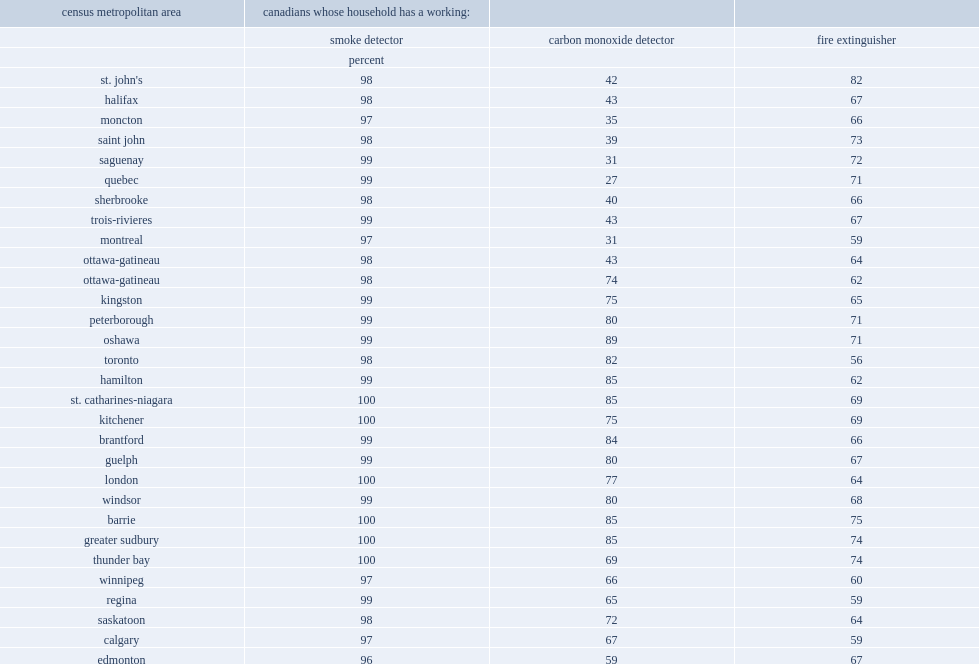Parse the table in full. {'header': ['census metropolitan area', 'canadians whose household has a working:', '', ''], 'rows': [['', 'smoke detector', 'carbon monoxide detector', 'fire extinguisher'], ['', 'percent', '', ''], ["st. john's", '98', '42', '82'], ['halifax', '98', '43', '67'], ['moncton', '97', '35', '66'], ['saint john', '98', '39', '73'], ['saguenay', '99', '31', '72'], ['quebec', '99', '27', '71'], ['sherbrooke', '98', '40', '66'], ['trois-rivieres', '99', '43', '67'], ['montreal', '97', '31', '59'], ['ottawa-gatineau', '98', '43', '64'], ['ottawa-gatineau', '98', '74', '62'], ['kingston', '99', '75', '65'], ['peterborough', '99', '80', '71'], ['oshawa', '99', '89', '71'], ['toronto', '98', '82', '56'], ['hamilton', '99', '85', '62'], ['st. catharines-niagara', '100', '85', '69'], ['kitchener', '100', '75', '69'], ['brantford', '99', '84', '66'], ['guelph', '99', '80', '67'], ['london', '100', '77', '64'], ['windsor', '99', '80', '68'], ['barrie', '100', '85', '75'], ['greater sudbury', '100', '85', '74'], ['thunder bay', '100', '69', '74'], ['winnipeg', '97', '66', '60'], ['regina', '99', '65', '59'], ['saskatoon', '98', '72', '64'], ['calgary', '97', '67', '59'], ['edmonton', '96', '59', '67'], ['kelowna', '98', '65', '74'], ['abbotsford-mission', '99', '54', '64'], ['vancouver', '94', '51', '64'], ['victoria', '98', '47', '74'], ['canada', '98', '60', '66']]} Looking at canada's census metropolitan areas (cma), what is the percentage of carbon monoxide detectors were found most frequently among individuals living in oshawa in 2014? 89.0. In contrast, individuals from the quebec cmas of quebec had the lowest proportions of carbon monoxide detectors, what is the percentage of it? 27.0. In contrast, individuals from the quebec cmas of saguenay had the lowest proportions of carbon monoxide detectors, what is the percentage of it? 31.0. In contrast, individuals from the quebec cmas of montreal had the lowest proportions of carbon monoxide detectors, what is the percentage of it? 31.0. What is the percentage of individuals in st. john's reported the highest proportion of fire extinguishers in 2014? 82.0. What is the percentage of individuals in barrie reported the highest proportion of fire extinguishers in 2014? 75.0. 